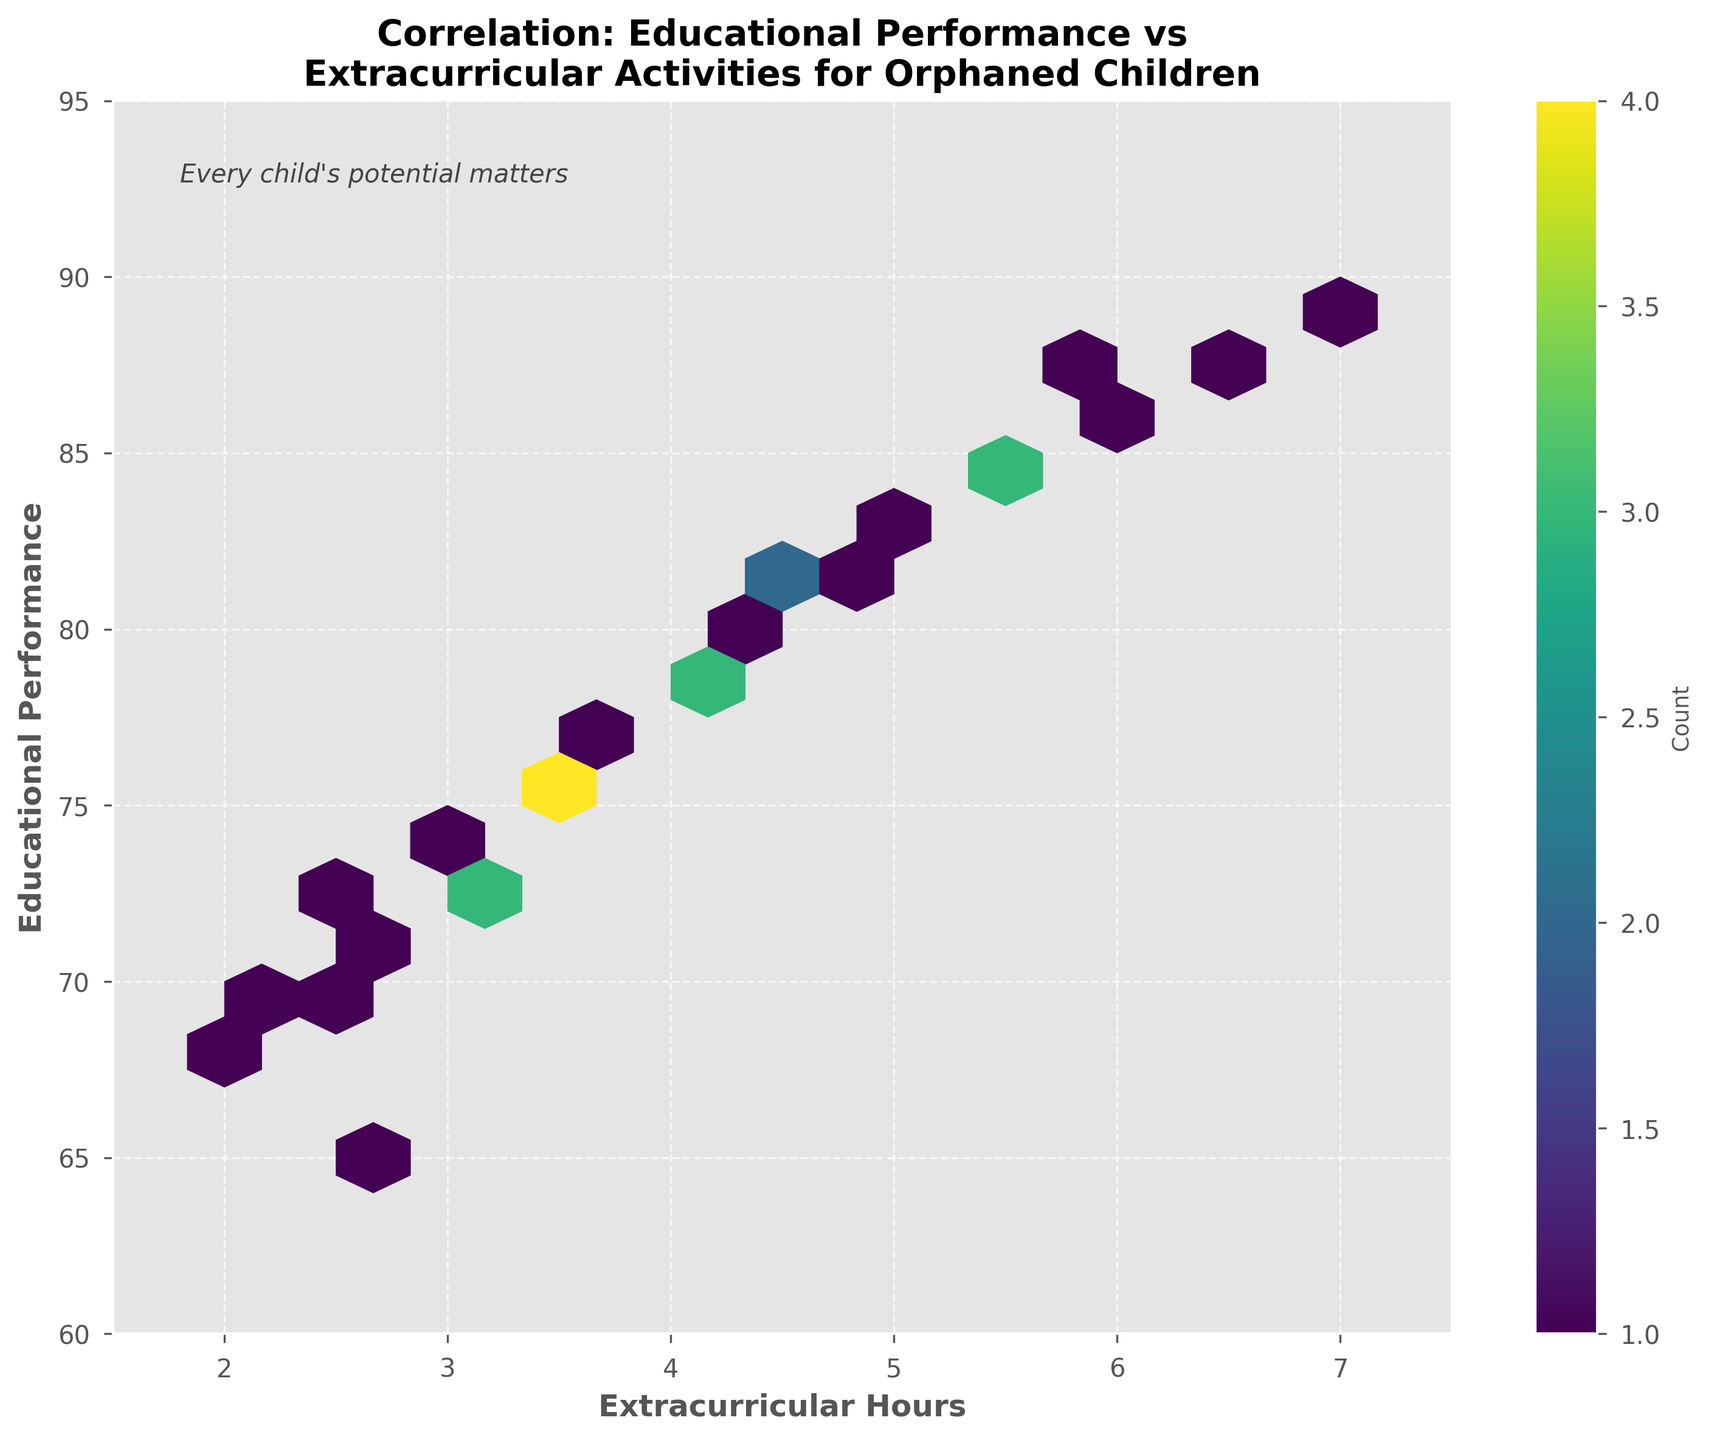What is the title of the plot? The title is displayed at the top of the plot. It states the main idea or the subject being visualized.
Answer: Correlation: Educational Performance vs Extracurricular Activities for Orphaned Children What does the color gradient represent in the hexbin plot? By examining the color bar, we see that the gradient reflects the count of data points in each hexbin. The color varies from lighter shades to darker shades, indicating fewer to more data points respectively.
Answer: Count of data points What is the range of educational performance scores depicted in the plot? The y-axis represents Educational Performance, and the limits are set between 60 and 95. This can be observed from the labels on the y-axis.
Answer: 60 to 95 How many hexagons correspond to a count of at least 5 children? By referring to the color bar and observing the various hexagons in the plot, count only the ones with the shade that corresponds to a count of at least 5 or more. We can identify several such hexagons.
Answer: Several (exact number can vary) What relationship can be inferred between extracurricular hours and educational performance? By analyzing the distribution of hexagons, observe a positive trend where higher educational performance scores tend to cluster around higher extracurricular hours.
Answer: Positive correlation Which range of extracurricular hours sees the highest educational performance scores? Examine the x-axis for Extracurricular Hours and locate where the darker hexagons are clustered at the higher y-values of Educational Performance. This typically occurs around higher extracurricular hours.
Answer: Around 6-7 hours How many children spend more than 5 hours in extracurricular activities? Note the range on the x-axis for Extracurricular Hours, identify hexagons where the x-values are greater than 5, and sum the counts for these hexagons based on the color bar.
Answer: Multiple children Is there any child with less than 3 hours of extracurricular activities scoring above 80 in educational performance? Check the region to the left of the x-axis value 3 for any hexagons that align with y-axis values above 80.
Answer: No What conclusion can be drawn about children spending between 3 and 4 hours in extracurricular activities? By observing the hexagons within the 3 to 4 hours range on the x-axis, note the Educational Performance range and counts shown in those hexagons. These children typically score between 70 and 80.
Answer: Score between 70 and 80 Is there any child who has more than 6.5 hours of extracurricular activities? Check the x-axis for any hexagons that correspond to Extracurricular Hours greater than 6.5 hours.
Answer: Yes 